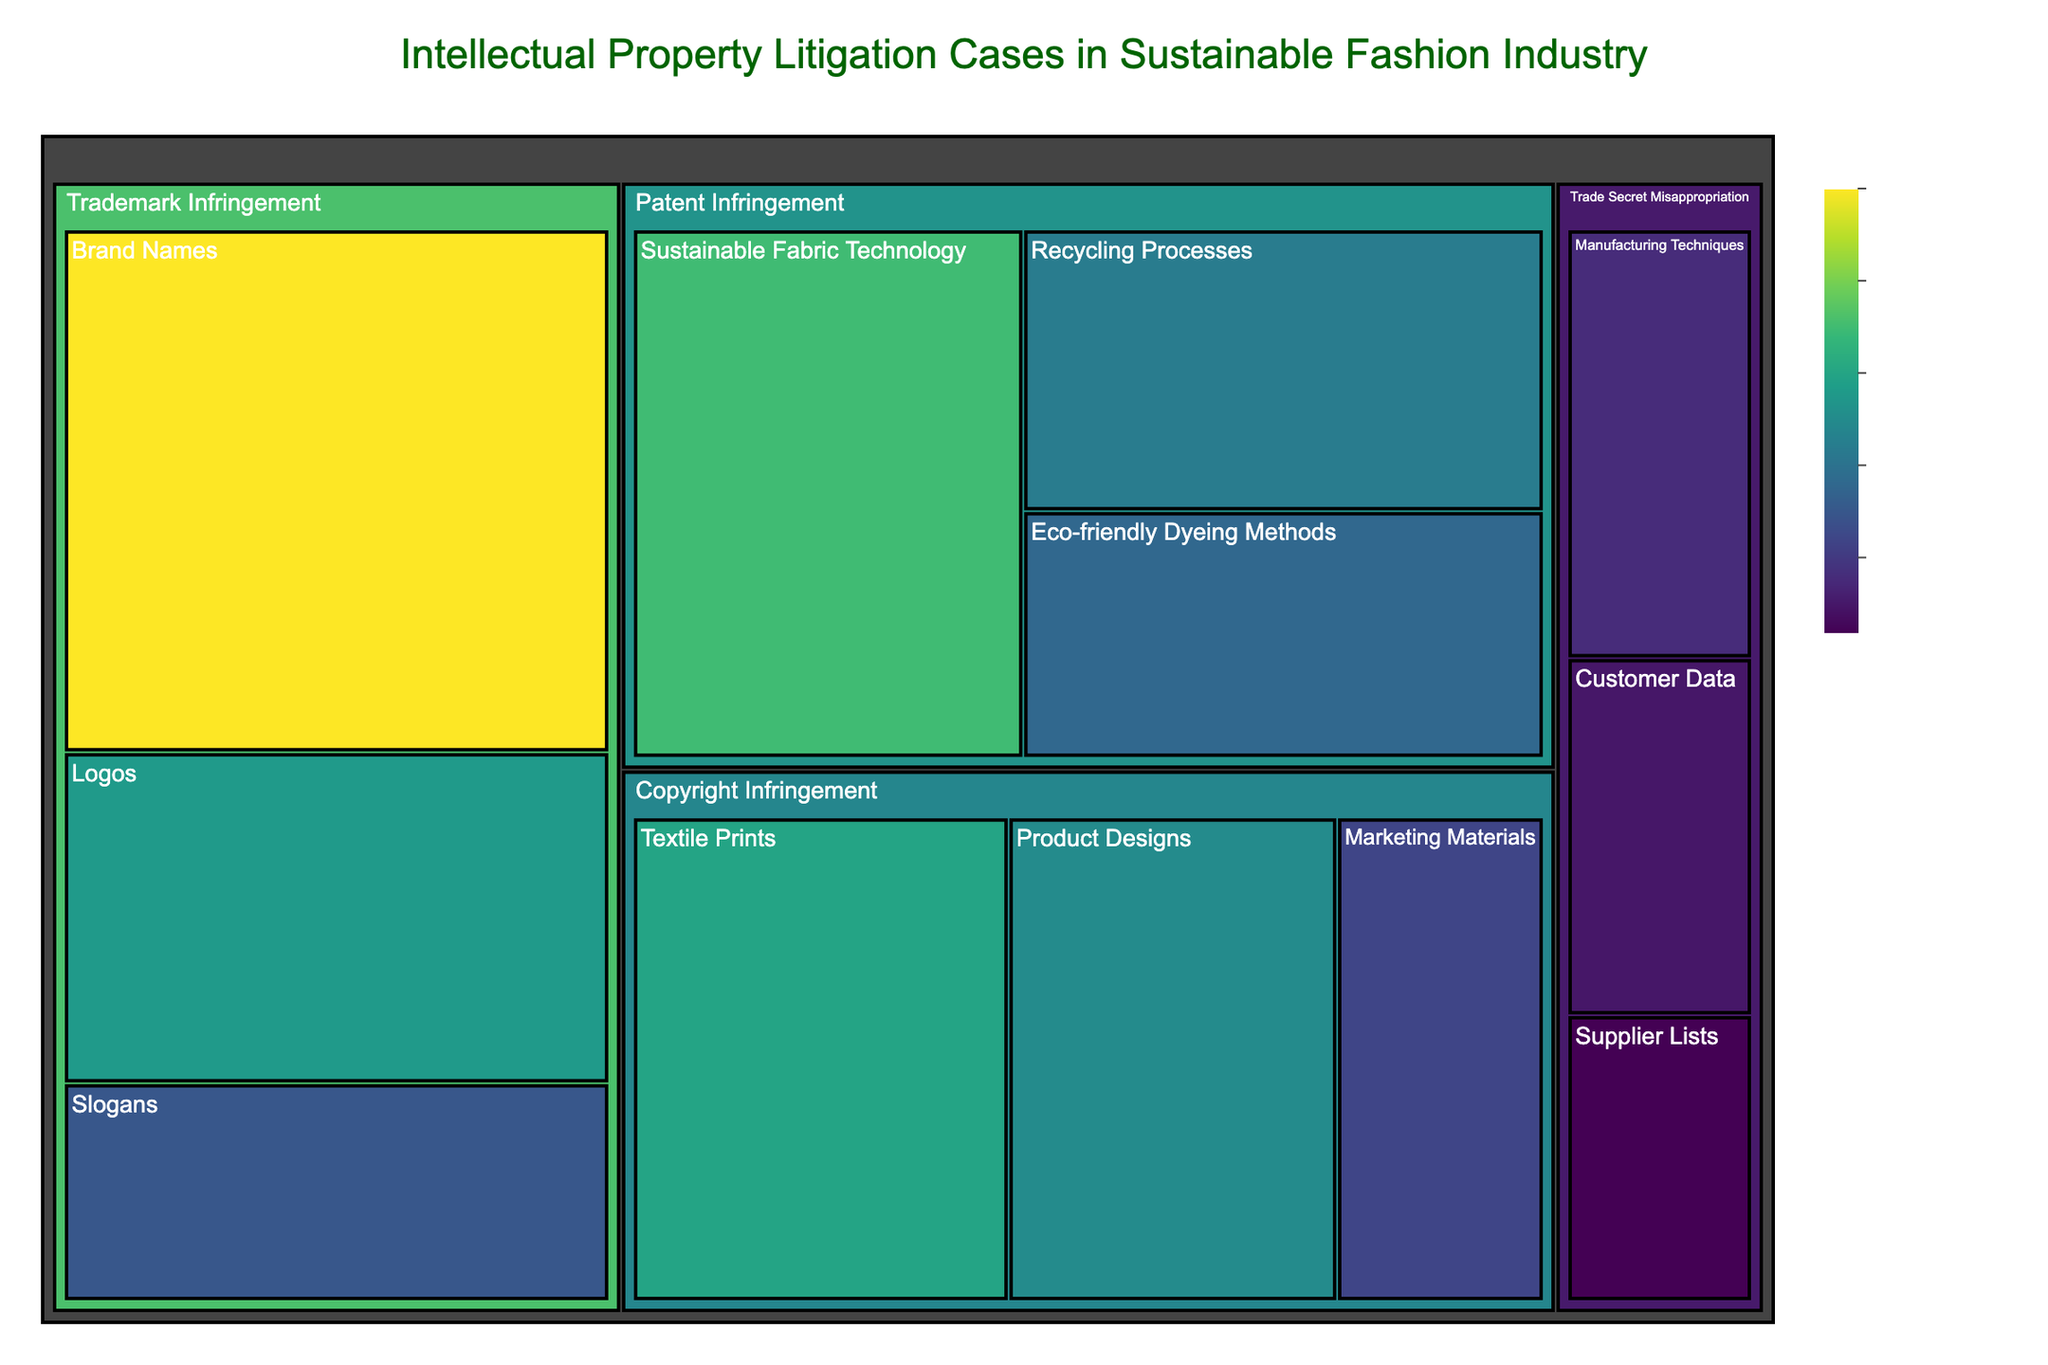What's the title of the figure? The title is located at the top of the treemap and is clearly displayed.
Answer: Intellectual Property Litigation Cases in Sustainable Fashion Industry How many total cases are there in the category of Patent Infringement? To find the total number of cases in Patent Infringement, sum the values for all its subcategories: 45 (Sustainable Fabric Technology) + 32 (Recycling Processes) + 28 (Eco-friendly Dyeing Methods).
Answer: 105 Which subcategory has the highest number of cases in Trademark Infringement? By comparing the values for each subcategory under Trademark Infringement: Brand Names (60), Logos (38), and Slogans (25), the subcategory with the highest number is Brand Names.
Answer: Brand Names What is the difference in the number of cases between the subcategories of Textile Prints and Product Designs in Copyright Infringement? Subtract the number of cases in Product Designs (35) from the number of cases in Textile Prints (40).
Answer: 5 Compare the total number of cases in Patent Infringement to Trademark Infringement. Which one has more cases? First, sum the total cases in each category. The total for Trademark Infringement is 60 (Brand Names) + 38 (Logos) + 25 (Slogans) = 123. For Patent Infringement, it's 105. Since 123 is greater than 105, Trademark Infringement has more cases.
Answer: Trademark Infringement Which subcategory in Trade Secret Misappropriation has the fewest number of cases? Comparing the subcategories under Trade Secret Misappropriation: Manufacturing Techniques (18), Supplier Lists (12), and Customer Data (15), Supplier Lists has the fewest number of cases.
Answer: Supplier Lists What category has the highest number of cases overall and how many are there? Look for the highest values for each category. The total for Trademark Infringement is 123, for Patent Infringement is 105, for Copyright Infringement is 97, and for Trade Secret Misappropriation is 45. The highest is Trademark Infringement with 123 cases.
Answer: Trademark Infringement, 123 How many total cases are there in the figure? Sum the values of all categories and subcategories: 45 + 32 + 28 + 60 + 38 + 25 + 40 + 22 + 35 + 18 + 12 + 15.
Answer: 370 What is the average number of cases in the subcategories of Copyright Infringement? Sum the values for the subcategories under Copyright Infringement: 40 (Textile Prints) + 22 (Marketing Materials) + 35 (Product Designs) = 97 cases. There are 3 subcategories, so divide by 3.
Answer: 32.33 